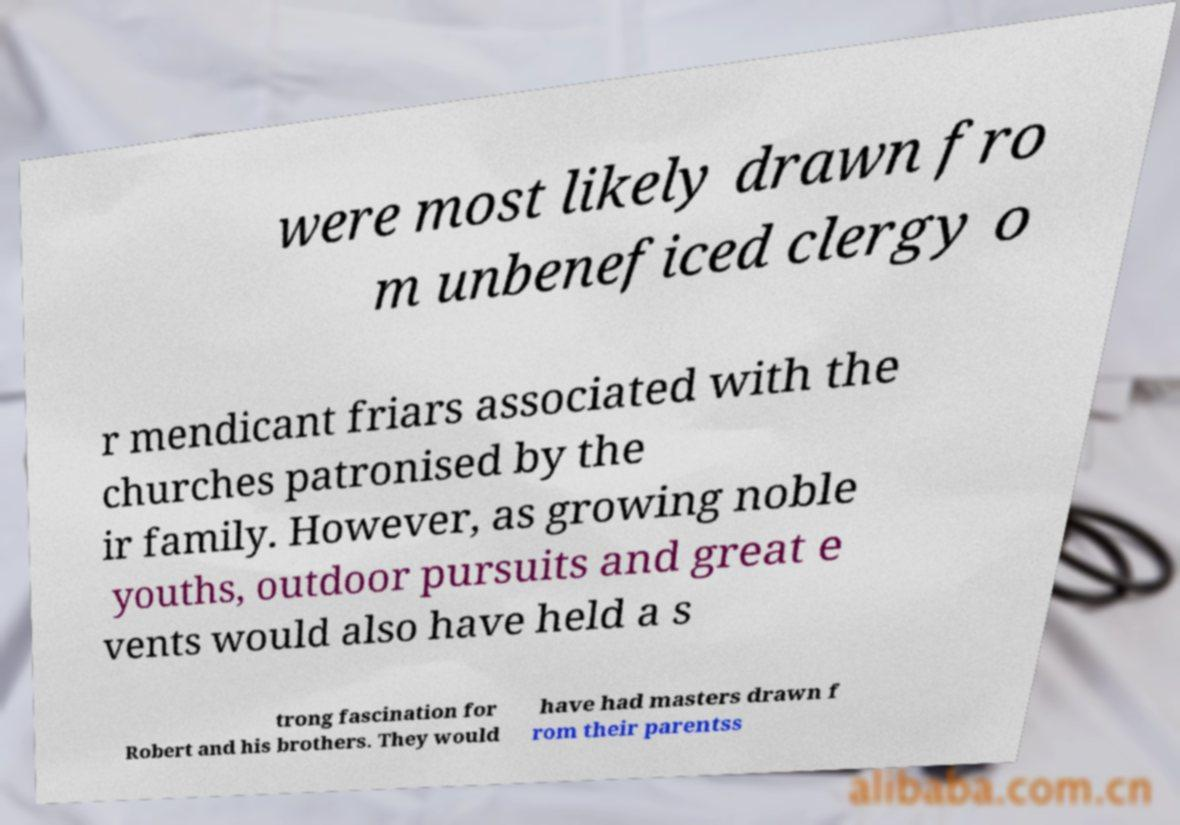There's text embedded in this image that I need extracted. Can you transcribe it verbatim? were most likely drawn fro m unbeneficed clergy o r mendicant friars associated with the churches patronised by the ir family. However, as growing noble youths, outdoor pursuits and great e vents would also have held a s trong fascination for Robert and his brothers. They would have had masters drawn f rom their parentss 